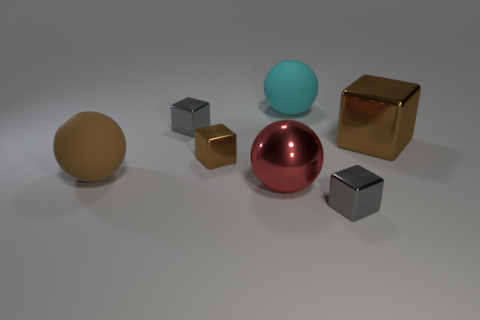Can you describe the different materials that the objects in this image appear to be made of? Certainly! The objects in the image consist of various appearances that suggest different materials. The large ball in the center with a reflective surface seems to be made of a polished metal or perhaps a reflective plastic. The matte object on the left appears to be made of a dull metal or matte plastic surface. Lastly, the two cubes and the object on the right have reflective surfaces that might indicate metallic materials, potentially gold and silver. 